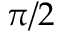<formula> <loc_0><loc_0><loc_500><loc_500>\pi / 2</formula> 